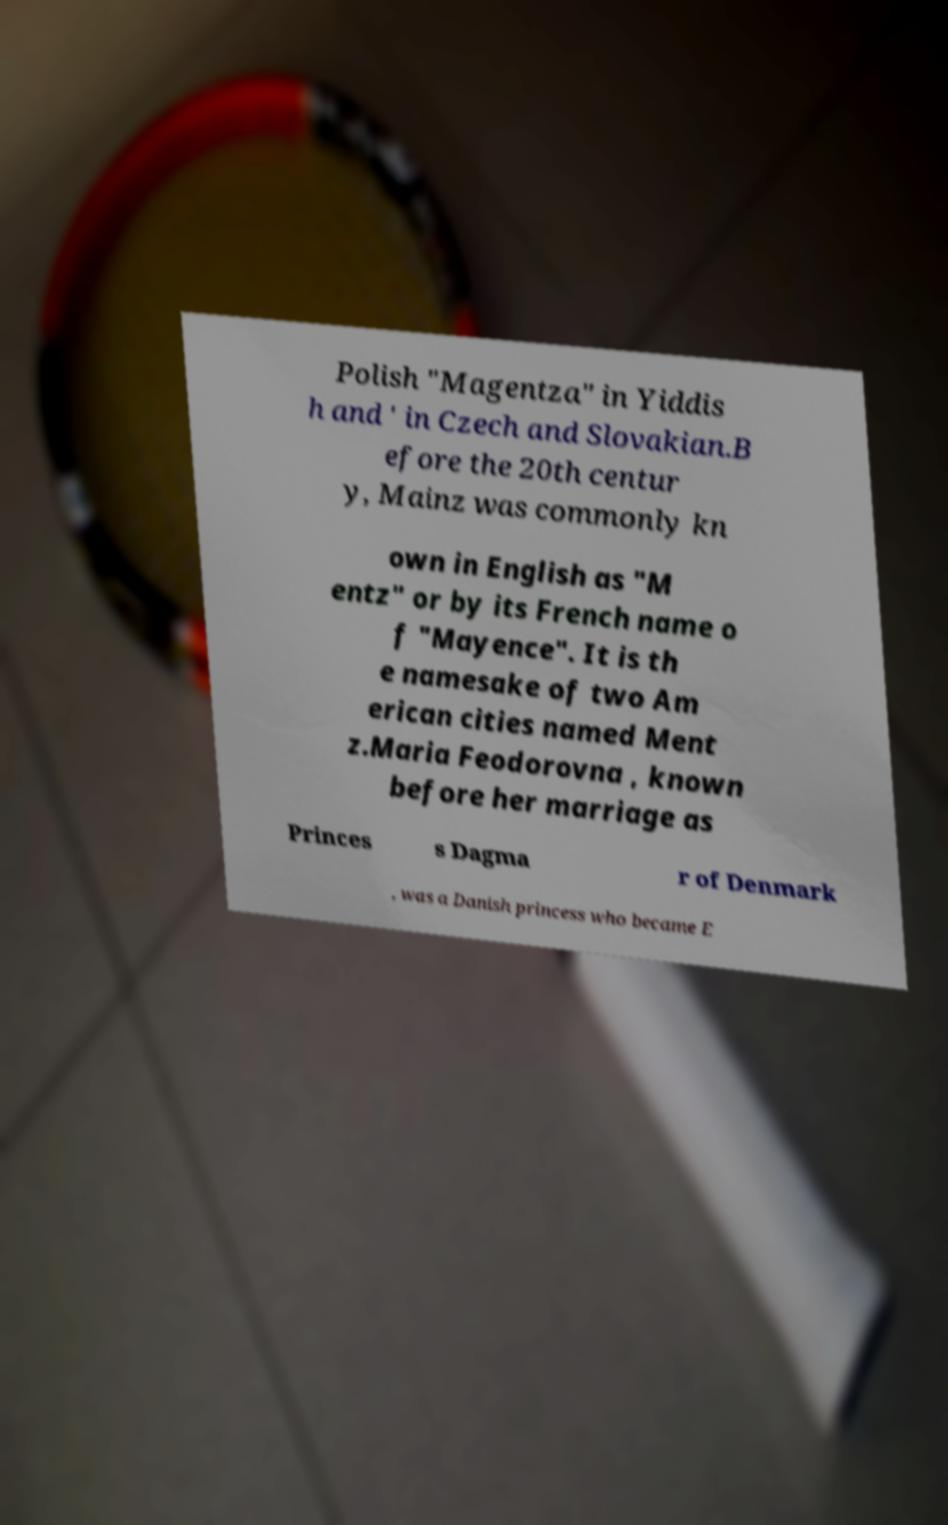Please identify and transcribe the text found in this image. Polish "Magentza" in Yiddis h and ' in Czech and Slovakian.B efore the 20th centur y, Mainz was commonly kn own in English as "M entz" or by its French name o f "Mayence". It is th e namesake of two Am erican cities named Ment z.Maria Feodorovna , known before her marriage as Princes s Dagma r of Denmark , was a Danish princess who became E 